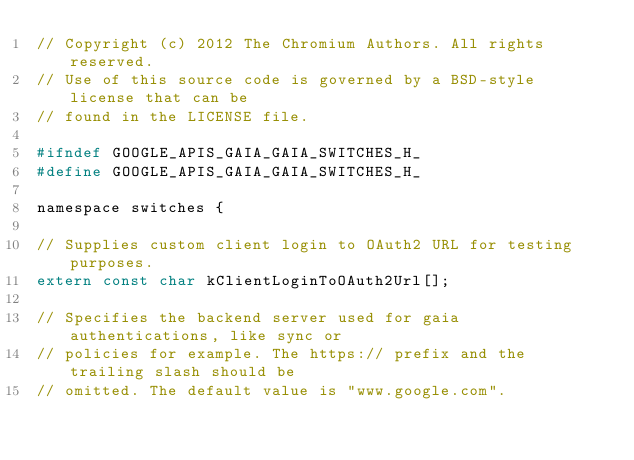<code> <loc_0><loc_0><loc_500><loc_500><_C_>// Copyright (c) 2012 The Chromium Authors. All rights reserved.
// Use of this source code is governed by a BSD-style license that can be
// found in the LICENSE file.

#ifndef GOOGLE_APIS_GAIA_GAIA_SWITCHES_H_
#define GOOGLE_APIS_GAIA_GAIA_SWITCHES_H_

namespace switches {

// Supplies custom client login to OAuth2 URL for testing purposes.
extern const char kClientLoginToOAuth2Url[];

// Specifies the backend server used for gaia authentications, like sync or
// policies for example. The https:// prefix and the trailing slash should be
// omitted. The default value is "www.google.com".</code> 